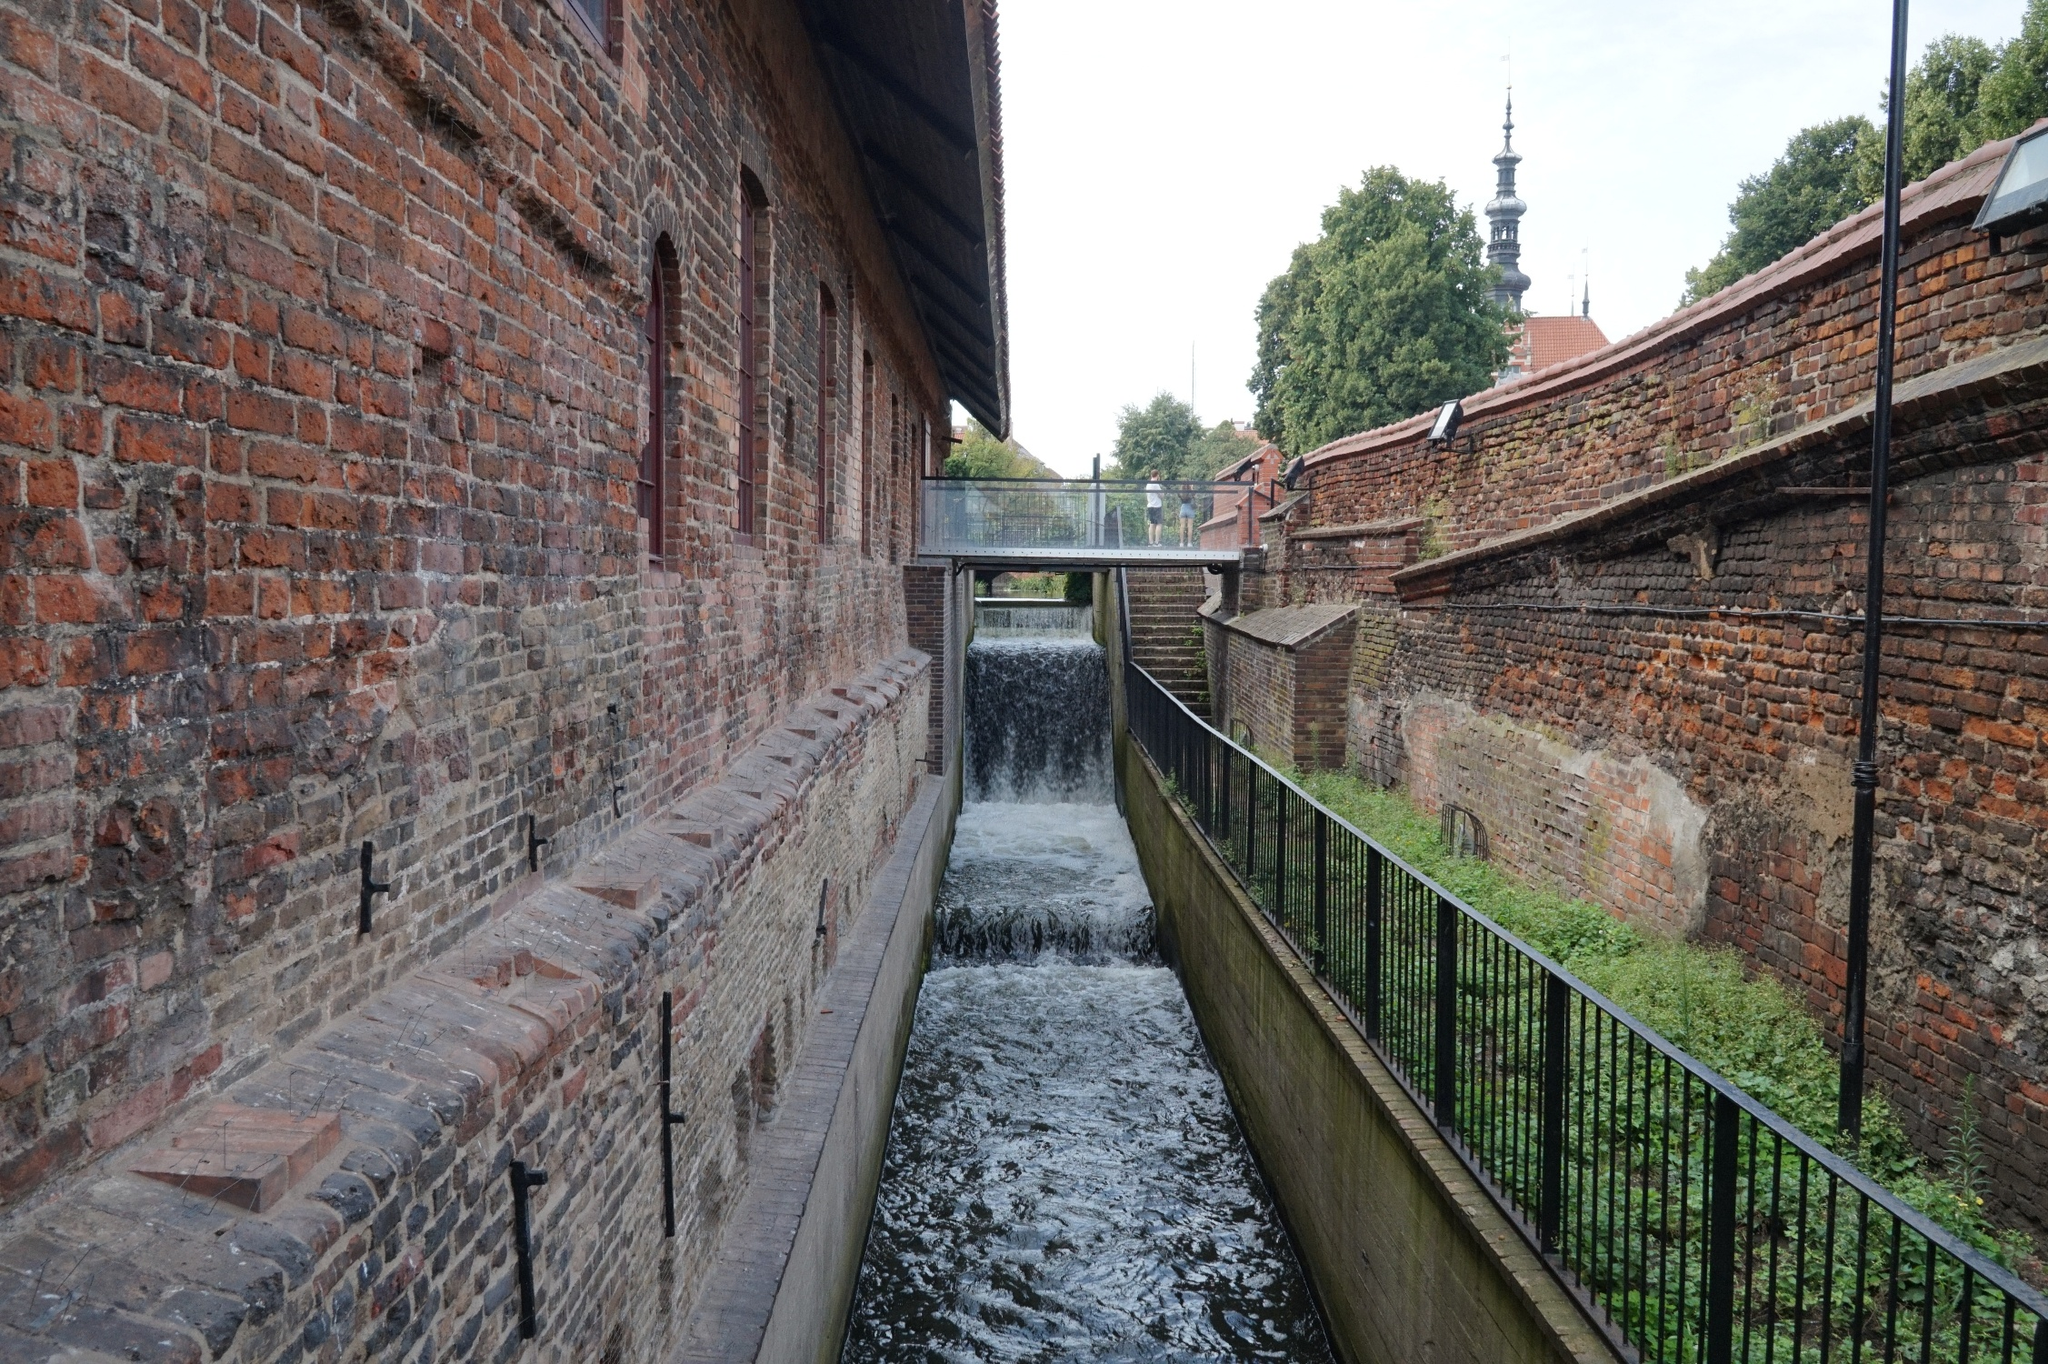Can you describe the main architectural features in this photo? The photo showcases a blend of rustic and urban architectural features. The main building on the left is constructed with traditional red bricks, featuring multiple evenly spaced, arched windows that add to its historical charm. The wooden roof and brick chimney enhance its rustic appeal. Adjacent to the building is a wooden walkway supported by sturdy, dark wooden beams, extending across a narrow canal. The canal itself is framed by brick walls with occasional signs of wear and age, contributing to the area's historic atmosphere. In the background, a tall church spire punctuates the skyline, combining traditional religious architecture with the urban setting. 